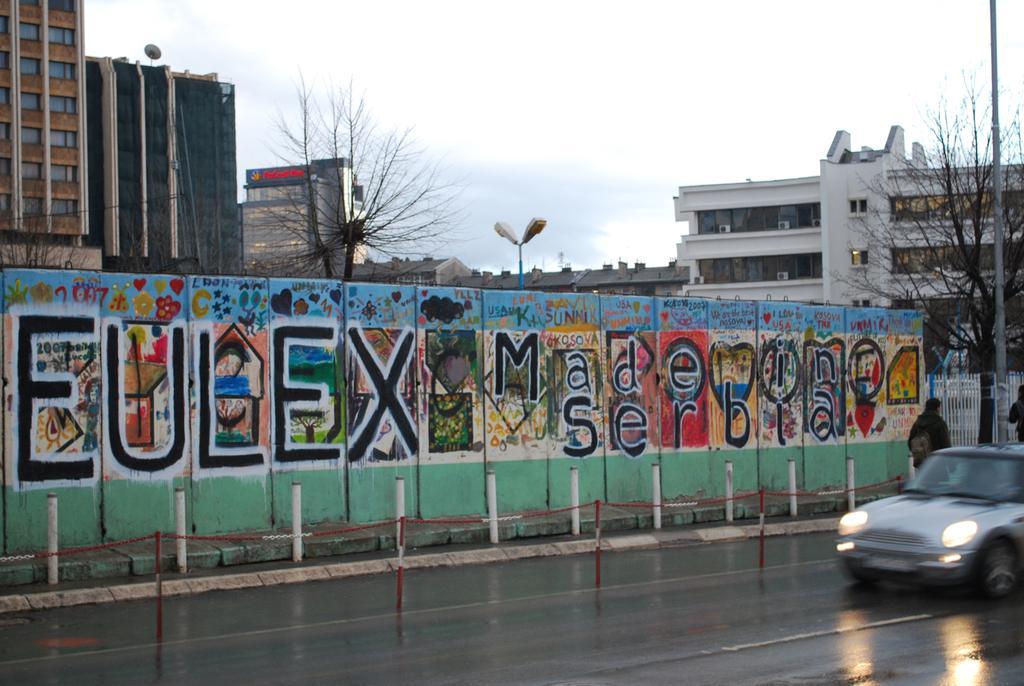In one or two sentences, can you explain what this image depicts? This is a picture taken outside a city. In the foreground there is a road. To the right there is a car. Road is wet. In the center of the picture there is a wall painted, before the wall there is footpath and railing. To the right there is a tree and a pole. In the center of the picture there is a tree and a street light. In the background there are buildings. Sky is cloudy. 